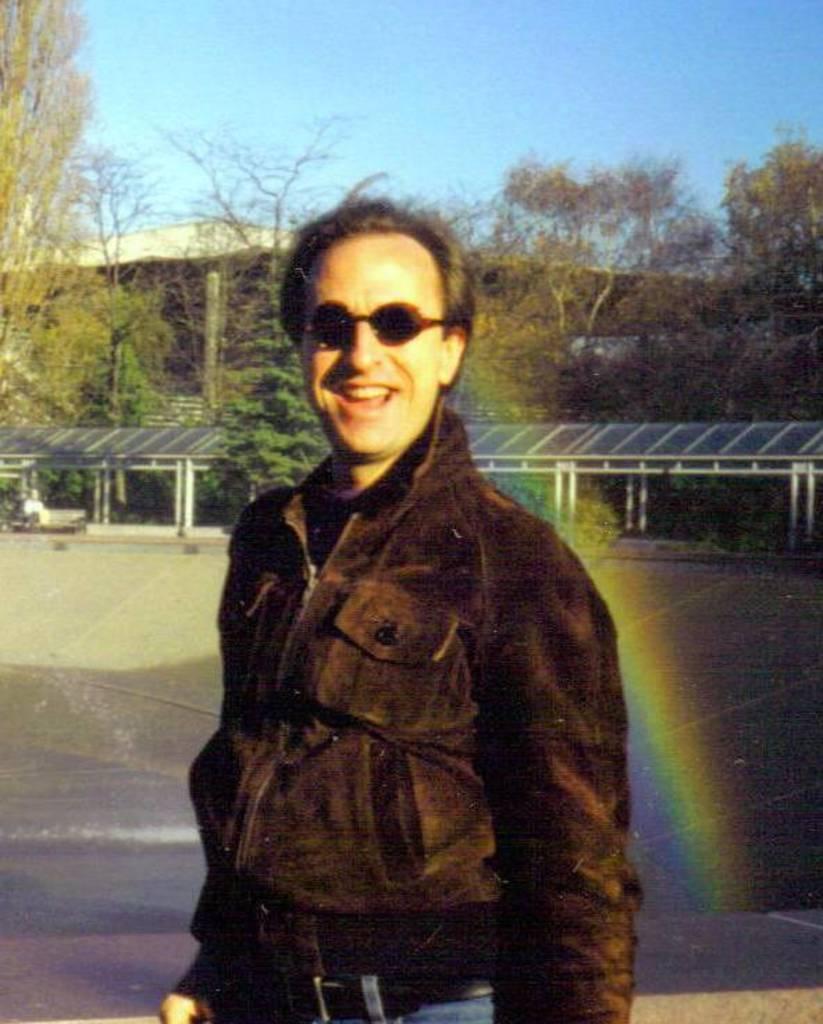Could you give a brief overview of what you see in this image? In this image we can see a person standing on the ground. On the right side of the image we can see a rainbow, some metal poles and group of trees. On the left side of the image we can see a building. At the top of the image we can see the sky. 